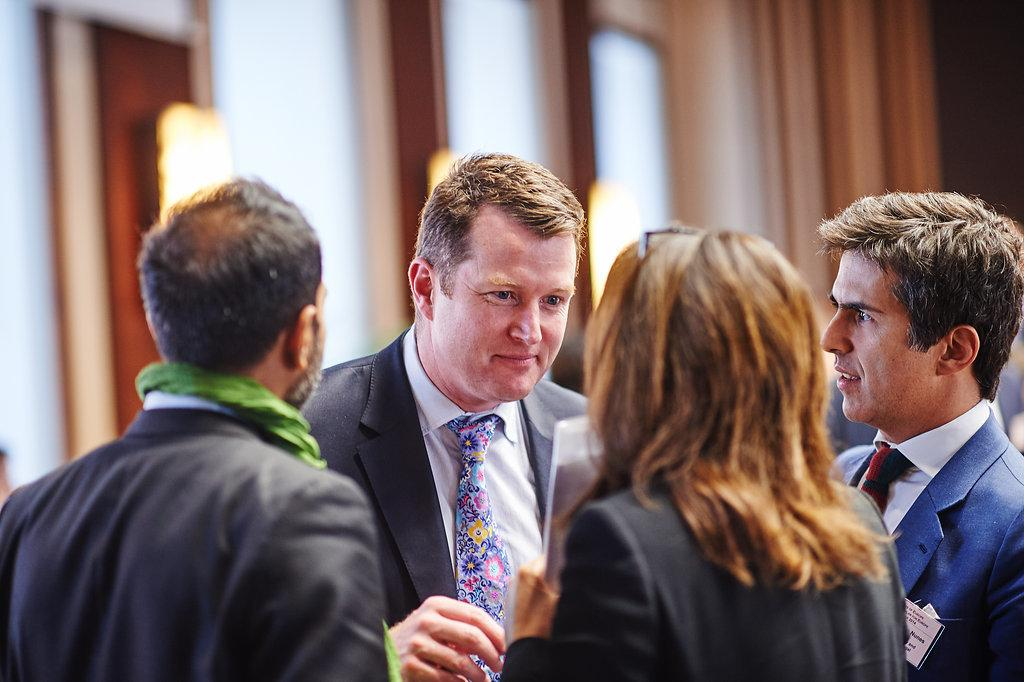How many people are in the image? There are four persons in the image. How many of them are men? There are three men in the image. What are the men wearing? The men are wearing suits and ties. What is the woman doing in the image? The woman appears to be holding a file. What type of duck can be seen in the image? There is no duck present in the image. What kind of structure is visible in the background of the image? The provided facts do not mention any structure in the background of the image. 